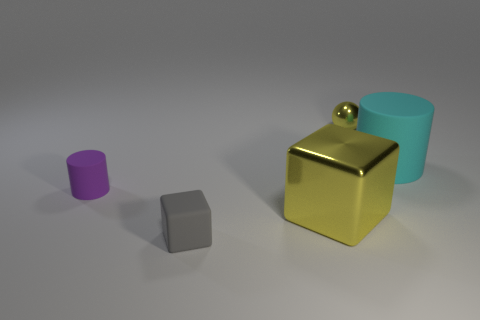Add 2 tiny matte cubes. How many objects exist? 7 Subtract all cubes. How many objects are left? 3 Add 2 blocks. How many blocks exist? 4 Subtract 0 gray balls. How many objects are left? 5 Subtract all tiny yellow metal balls. Subtract all yellow blocks. How many objects are left? 3 Add 5 gray matte cubes. How many gray matte cubes are left? 6 